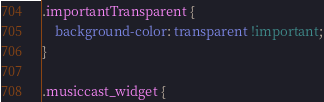<code> <loc_0><loc_0><loc_500><loc_500><_CSS_>.importantTransparent {
    background-color: transparent !important;
}

.musiccast_widget {</code> 